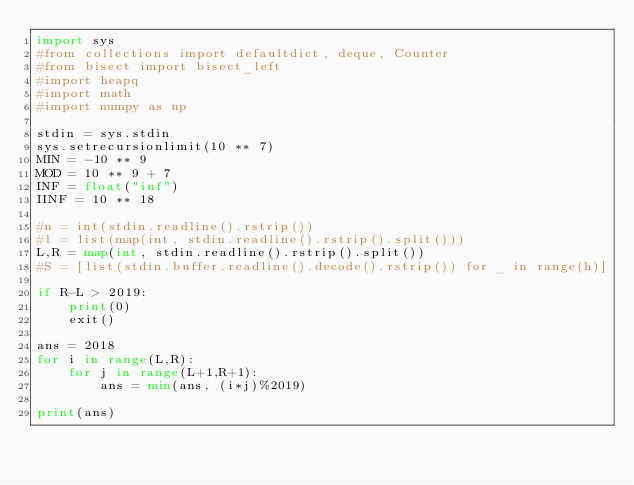Convert code to text. <code><loc_0><loc_0><loc_500><loc_500><_Python_>import sys
#from collections import defaultdict, deque, Counter
#from bisect import bisect_left
#import heapq
#import math
#import numpy as np

stdin = sys.stdin
sys.setrecursionlimit(10 ** 7)
MIN = -10 ** 9
MOD = 10 ** 9 + 7
INF = float("inf")
IINF = 10 ** 18

#n = int(stdin.readline().rstrip())
#l = list(map(int, stdin.readline().rstrip().split()))
L,R = map(int, stdin.readline().rstrip().split())
#S = [list(stdin.buffer.readline().decode().rstrip()) for _ in range(h)]

if R-L > 2019:
    print(0)
    exit()

ans = 2018
for i in range(L,R):
    for j in range(L+1,R+1):
        ans = min(ans, (i*j)%2019)

print(ans)
</code> 